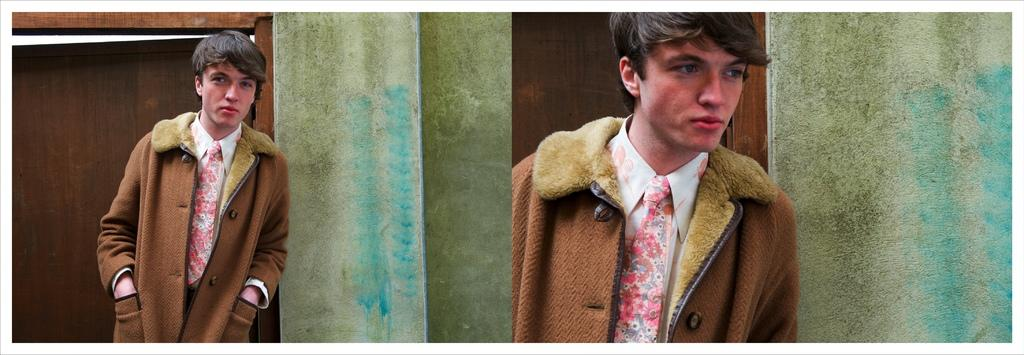How many men are present in the image? There are two men in the image, one on the left side and one on the right side. What can be seen in the background of the image? There is a wall and a door in the background of the image. What type of meat is being served at the attraction in the image? There is no attraction or meat present in the image; it features two men and a background with a wall and a door. 